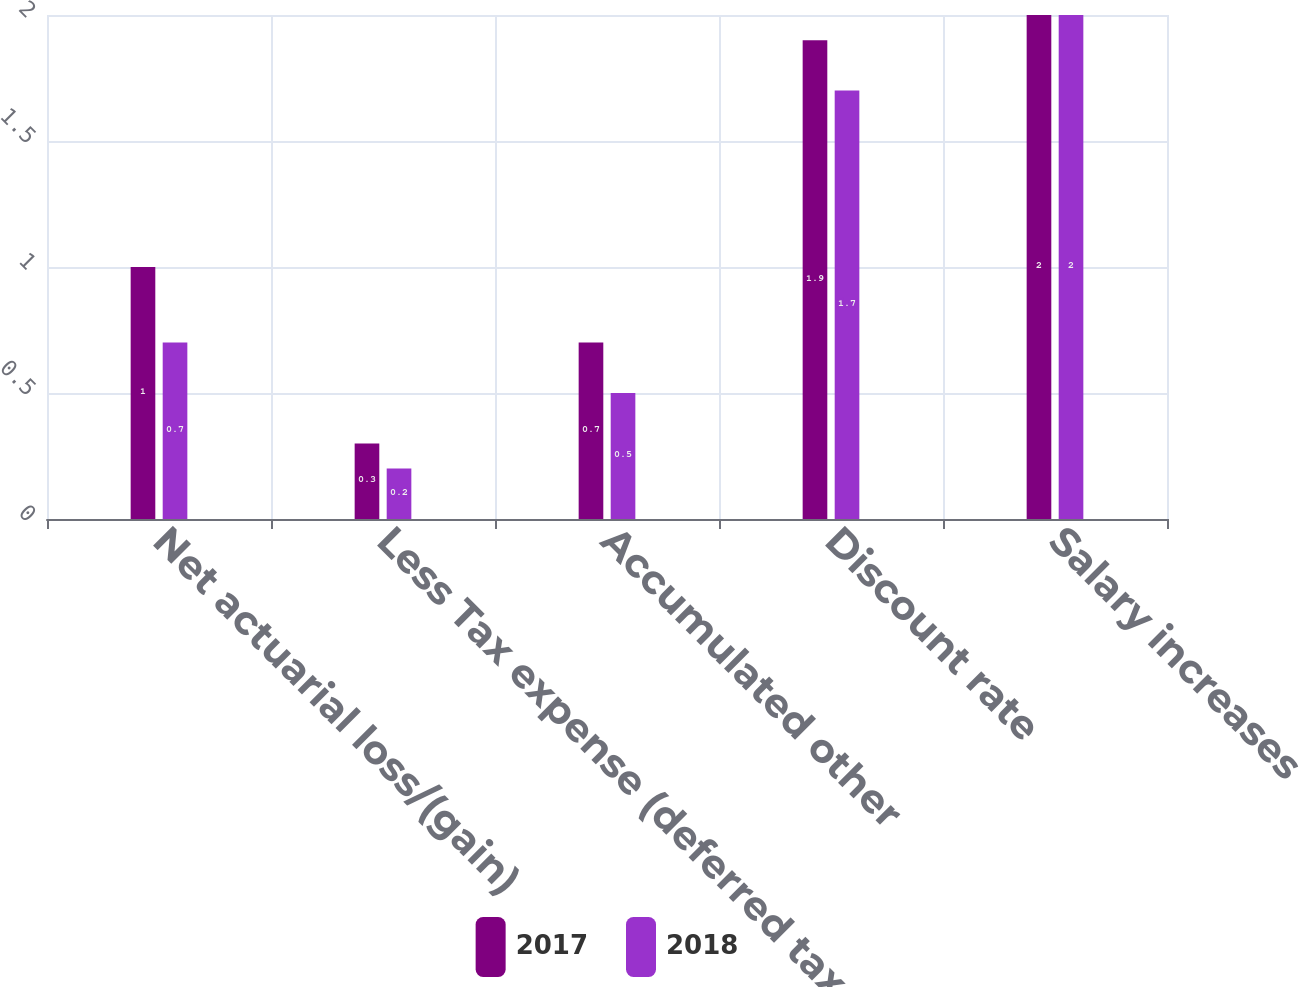Convert chart. <chart><loc_0><loc_0><loc_500><loc_500><stacked_bar_chart><ecel><fcel>Net actuarial loss/(gain)<fcel>Less Tax expense (deferred tax<fcel>Accumulated other<fcel>Discount rate<fcel>Salary increases<nl><fcel>2017<fcel>1<fcel>0.3<fcel>0.7<fcel>1.9<fcel>2<nl><fcel>2018<fcel>0.7<fcel>0.2<fcel>0.5<fcel>1.7<fcel>2<nl></chart> 